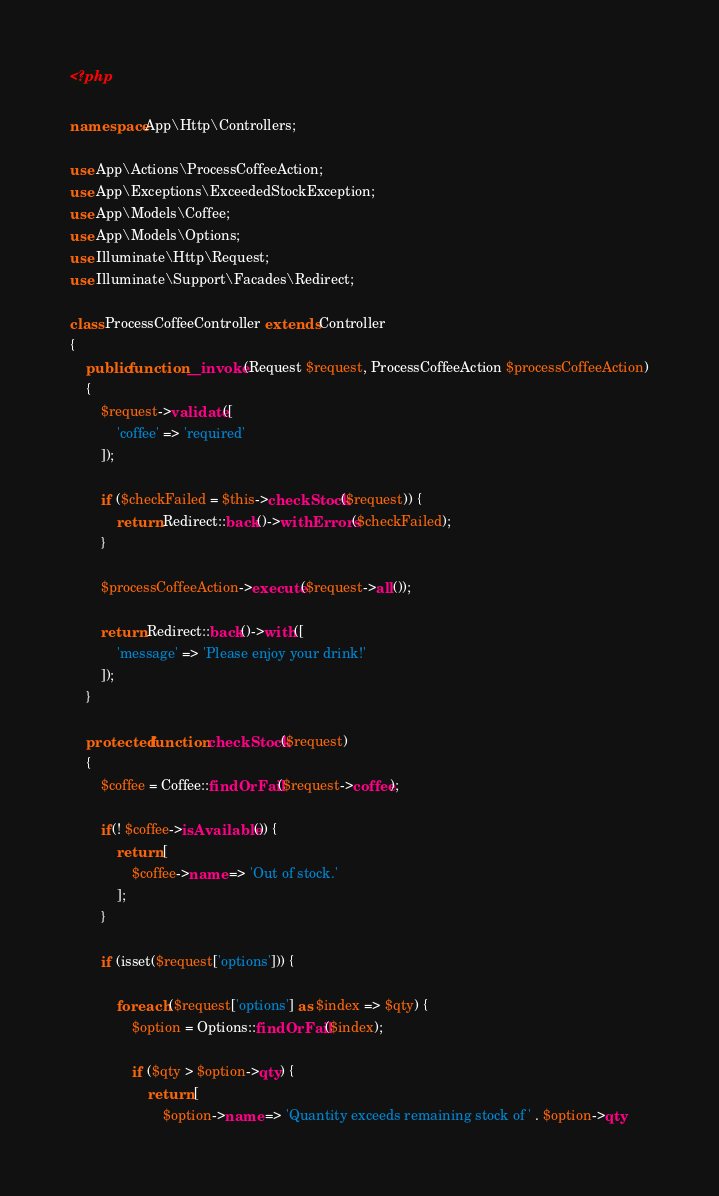<code> <loc_0><loc_0><loc_500><loc_500><_PHP_><?php

namespace App\Http\Controllers;

use App\Actions\ProcessCoffeeAction;
use App\Exceptions\ExceededStockException;
use App\Models\Coffee;
use App\Models\Options;
use Illuminate\Http\Request;
use Illuminate\Support\Facades\Redirect;

class ProcessCoffeeController extends Controller
{
    public function __invoke(Request $request, ProcessCoffeeAction $processCoffeeAction)
    {
        $request->validate([
            'coffee' => 'required'
        ]);

        if ($checkFailed = $this->checkStock($request)) {
            return Redirect::back()->withErrors($checkFailed);
        }

        $processCoffeeAction->execute($request->all());

        return Redirect::back()->with([
            'message' => 'Please enjoy your drink!'
        ]);
    }

    protected function checkStock($request)
    {
        $coffee = Coffee::findOrFail($request->coffee);

        if(! $coffee->isAvailable()) {
            return [
                $coffee->name => 'Out of stock.'
            ];
        }

        if (isset($request['options'])) {

            foreach ($request['options'] as $index => $qty) {
                $option = Options::findOrFail($index);

                if ($qty > $option->qty) {
                    return [
                        $option->name => 'Quantity exceeds remaining stock of ' . $option->qty</code> 